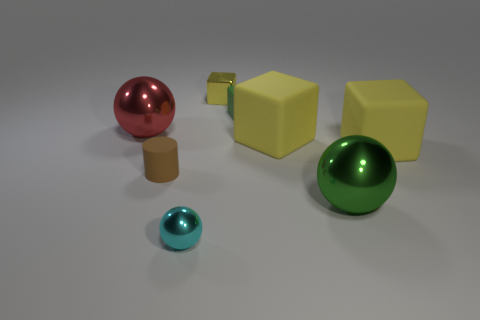How many objects are on the left side of the rubber cylinder and on the right side of the large green ball?
Your answer should be compact. 0. There is a large green thing that is in front of the small cylinder; what shape is it?
Your response must be concise. Sphere. How many yellow matte things have the same size as the yellow metal object?
Provide a succinct answer. 0. There is a big shiny object that is in front of the red metal object; is it the same color as the tiny sphere?
Keep it short and to the point. No. There is a ball that is on the right side of the red shiny object and to the left of the yellow shiny thing; what is its material?
Make the answer very short. Metal. Is the number of large shiny balls greater than the number of yellow metallic blocks?
Make the answer very short. Yes. What color is the ball that is on the right side of the large yellow rubber thing to the left of the big metallic object that is to the right of the red sphere?
Keep it short and to the point. Green. Are the block to the left of the green rubber block and the small brown thing made of the same material?
Offer a terse response. No. Is there a tiny cylinder that has the same color as the metal cube?
Provide a short and direct response. No. Are there any big cyan metal objects?
Ensure brevity in your answer.  No. 